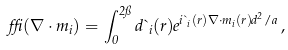<formula> <loc_0><loc_0><loc_500><loc_500>\delta ( \nabla \cdot { { m } _ { i } } ) = \int _ { 0 } ^ { 2 \pi } d \theta _ { i } ( { r } ) e ^ { i \theta _ { i } ( { r } ) \nabla \cdot { { m } _ { i } } ( { r } ) d ^ { 2 } / a } \, ,</formula> 